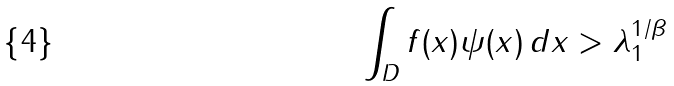<formula> <loc_0><loc_0><loc_500><loc_500>\int _ { D } f ( x ) \psi ( x ) \, d x > \lambda _ { 1 } ^ { 1 / \beta }</formula> 